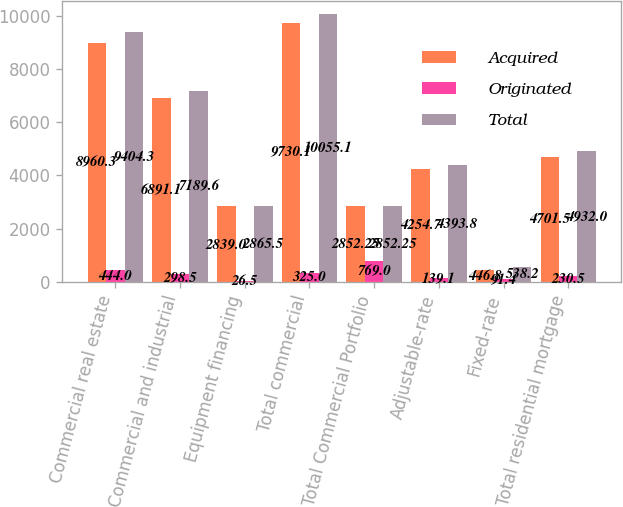Convert chart. <chart><loc_0><loc_0><loc_500><loc_500><stacked_bar_chart><ecel><fcel>Commercial real estate<fcel>Commercial and industrial<fcel>Equipment financing<fcel>Total commercial<fcel>Total Commercial Portfolio<fcel>Adjustable-rate<fcel>Fixed-rate<fcel>Total residential mortgage<nl><fcel>Acquired<fcel>8960.3<fcel>6891.1<fcel>2839<fcel>9730.1<fcel>2852.25<fcel>4254.7<fcel>446.8<fcel>4701.5<nl><fcel>Originated<fcel>444<fcel>298.5<fcel>26.5<fcel>325<fcel>769<fcel>139.1<fcel>91.4<fcel>230.5<nl><fcel>Total<fcel>9404.3<fcel>7189.6<fcel>2865.5<fcel>10055.1<fcel>2852.25<fcel>4393.8<fcel>538.2<fcel>4932<nl></chart> 